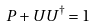Convert formula to latex. <formula><loc_0><loc_0><loc_500><loc_500>P + U U ^ { \dag } = 1</formula> 